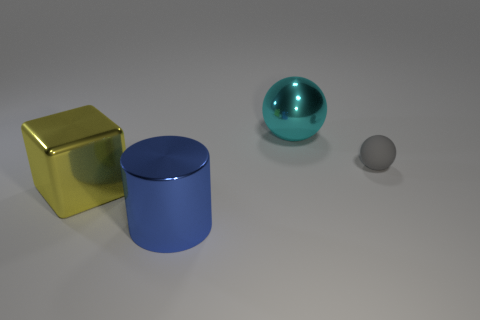What number of blue rubber cylinders are there?
Keep it short and to the point. 0. Is the material of the big object right of the large blue shiny thing the same as the tiny sphere that is behind the large yellow block?
Your answer should be very brief. No. What is the size of the ball that is the same material as the big cylinder?
Offer a terse response. Large. What is the shape of the large shiny object that is in front of the yellow cube?
Provide a short and direct response. Cylinder. There is a sphere that is to the right of the cyan metal sphere; does it have the same color as the big object that is behind the tiny ball?
Your answer should be very brief. No. Is there a blue metal cylinder?
Your response must be concise. Yes. What is the shape of the thing to the right of the big metal ball behind the object that is in front of the yellow block?
Offer a terse response. Sphere. There is a blue metallic object; how many yellow metal cubes are behind it?
Offer a very short reply. 1. Are the large thing in front of the large yellow cube and the cyan ball made of the same material?
Offer a very short reply. Yes. How many other things are the same shape as the gray matte thing?
Ensure brevity in your answer.  1. 